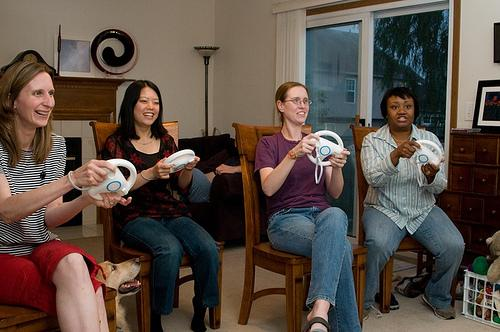What activity is the video game system simulating? Please explain your reasoning. driving. The activity is driving. 